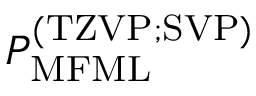<formula> <loc_0><loc_0><loc_500><loc_500>P _ { M F M L } ^ { ( T Z V P ; S V P ) }</formula> 